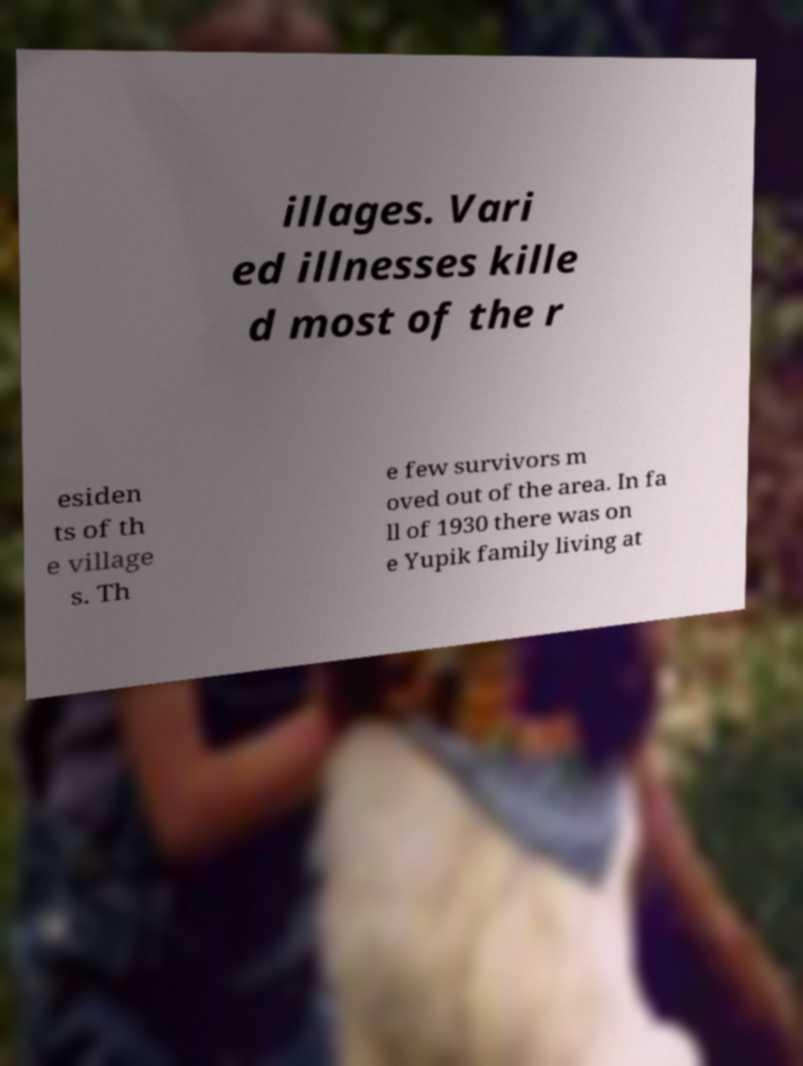For documentation purposes, I need the text within this image transcribed. Could you provide that? illages. Vari ed illnesses kille d most of the r esiden ts of th e village s. Th e few survivors m oved out of the area. In fa ll of 1930 there was on e Yupik family living at 